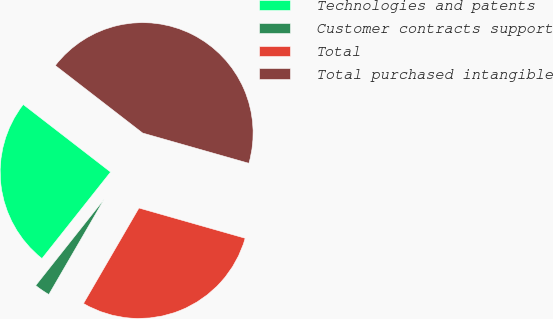<chart> <loc_0><loc_0><loc_500><loc_500><pie_chart><fcel>Technologies and patents<fcel>Customer contracts support<fcel>Total<fcel>Total purchased intangible<nl><fcel>24.8%<fcel>2.3%<fcel>28.96%<fcel>43.94%<nl></chart> 